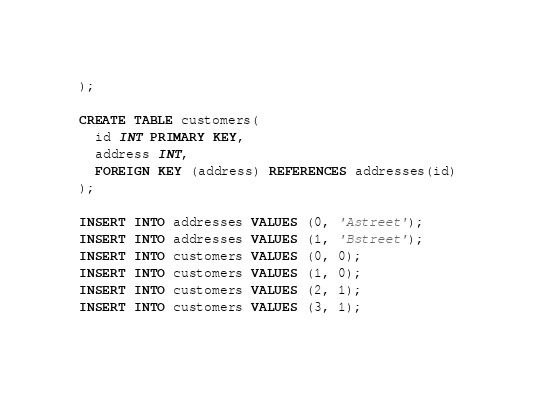Convert code to text. <code><loc_0><loc_0><loc_500><loc_500><_SQL_>);

CREATE TABLE customers(
  id INT PRIMARY KEY,
  address INT,
  FOREIGN KEY (address) REFERENCES addresses(id)
);

INSERT INTO addresses VALUES (0, 'Astreet');
INSERT INTO addresses VALUES (1, 'Bstreet');
INSERT INTO customers VALUES (0, 0);
INSERT INTO customers VALUES (1, 0);
INSERT INTO customers VALUES (2, 1);
INSERT INTO customers VALUES (3, 1);
</code> 